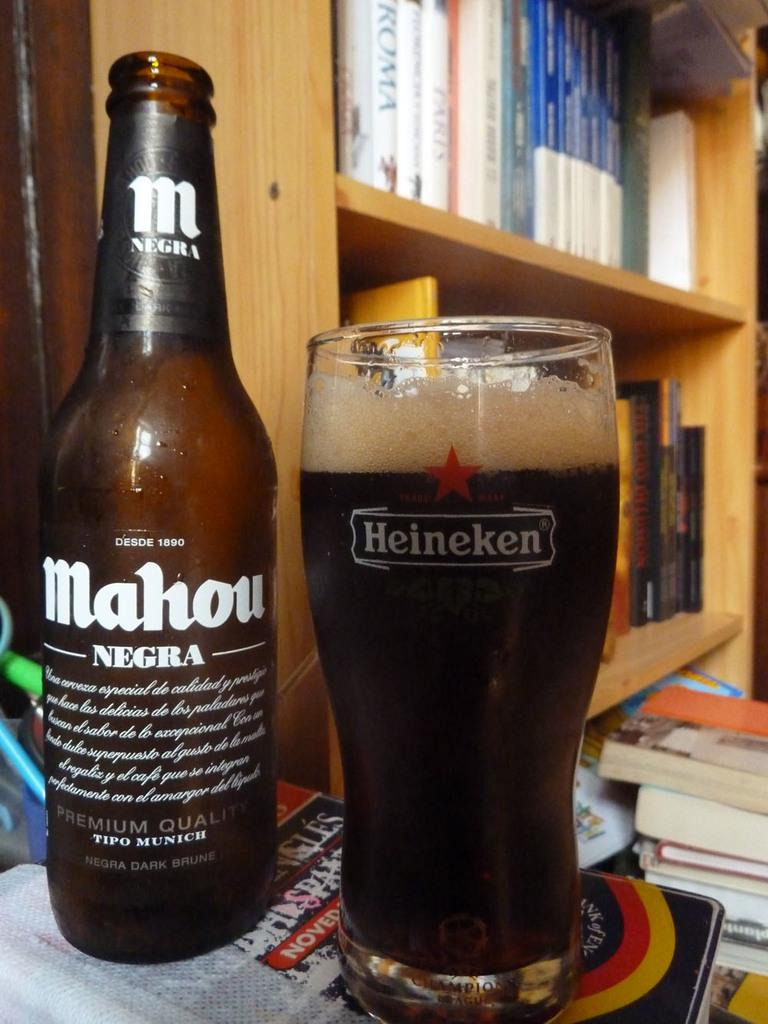<image>
Provide a brief description of the given image. Beer bottle that says Mahou next to a cup of beer. 